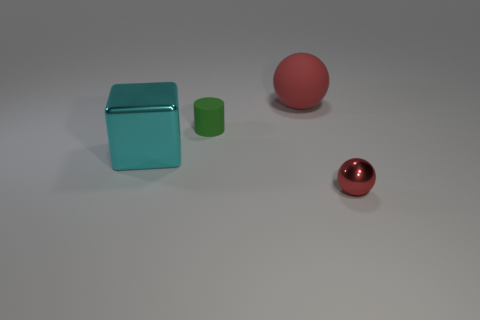There is a shiny object behind the red metal sphere; is its size the same as the rubber thing right of the tiny rubber cylinder?
Ensure brevity in your answer.  Yes. Are there fewer small green metal objects than tiny green matte objects?
Keep it short and to the point. Yes. How many matte things are either large objects or cylinders?
Your response must be concise. 2. There is a small green rubber thing in front of the large red thing; is there a green object on the left side of it?
Ensure brevity in your answer.  No. Does the big object left of the tiny green thing have the same material as the small red thing?
Give a very brief answer. Yes. How many other objects are there of the same color as the tiny metallic ball?
Offer a terse response. 1. Is the small rubber cylinder the same color as the metal ball?
Your answer should be very brief. No. What is the size of the red sphere in front of the red ball that is on the left side of the tiny red ball?
Provide a short and direct response. Small. Is the tiny object behind the small red object made of the same material as the ball in front of the green cylinder?
Offer a very short reply. No. There is a matte thing that is in front of the big rubber ball; does it have the same color as the shiny block?
Keep it short and to the point. No. 